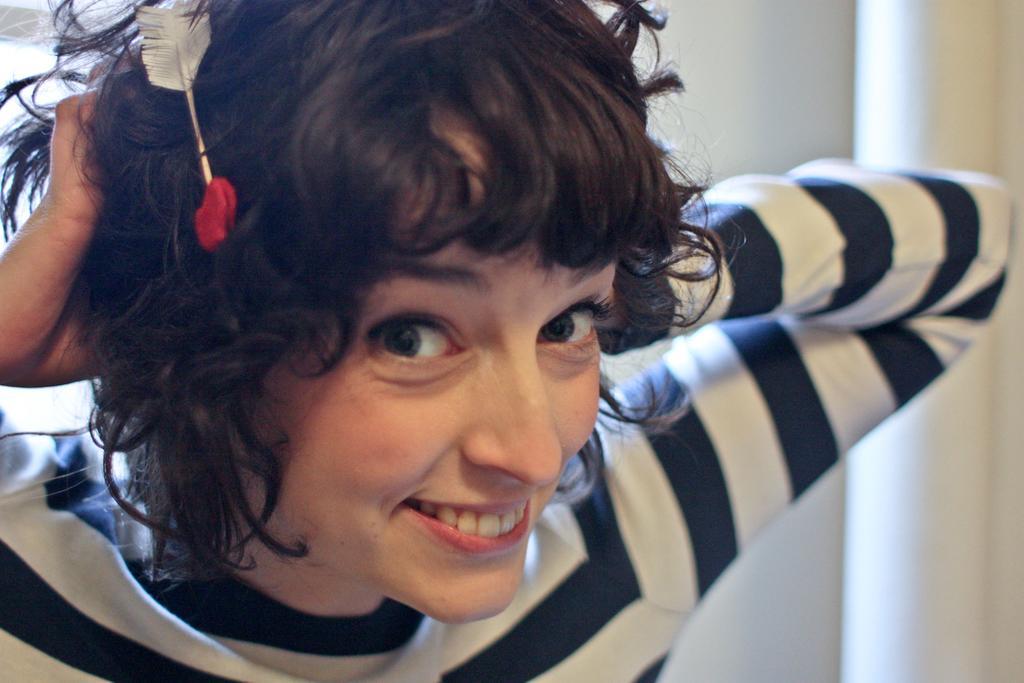Please provide a concise description of this image. In this image there is a woman with a smile on her face and there is an object on her head. In the background there is a curtain in white color. 